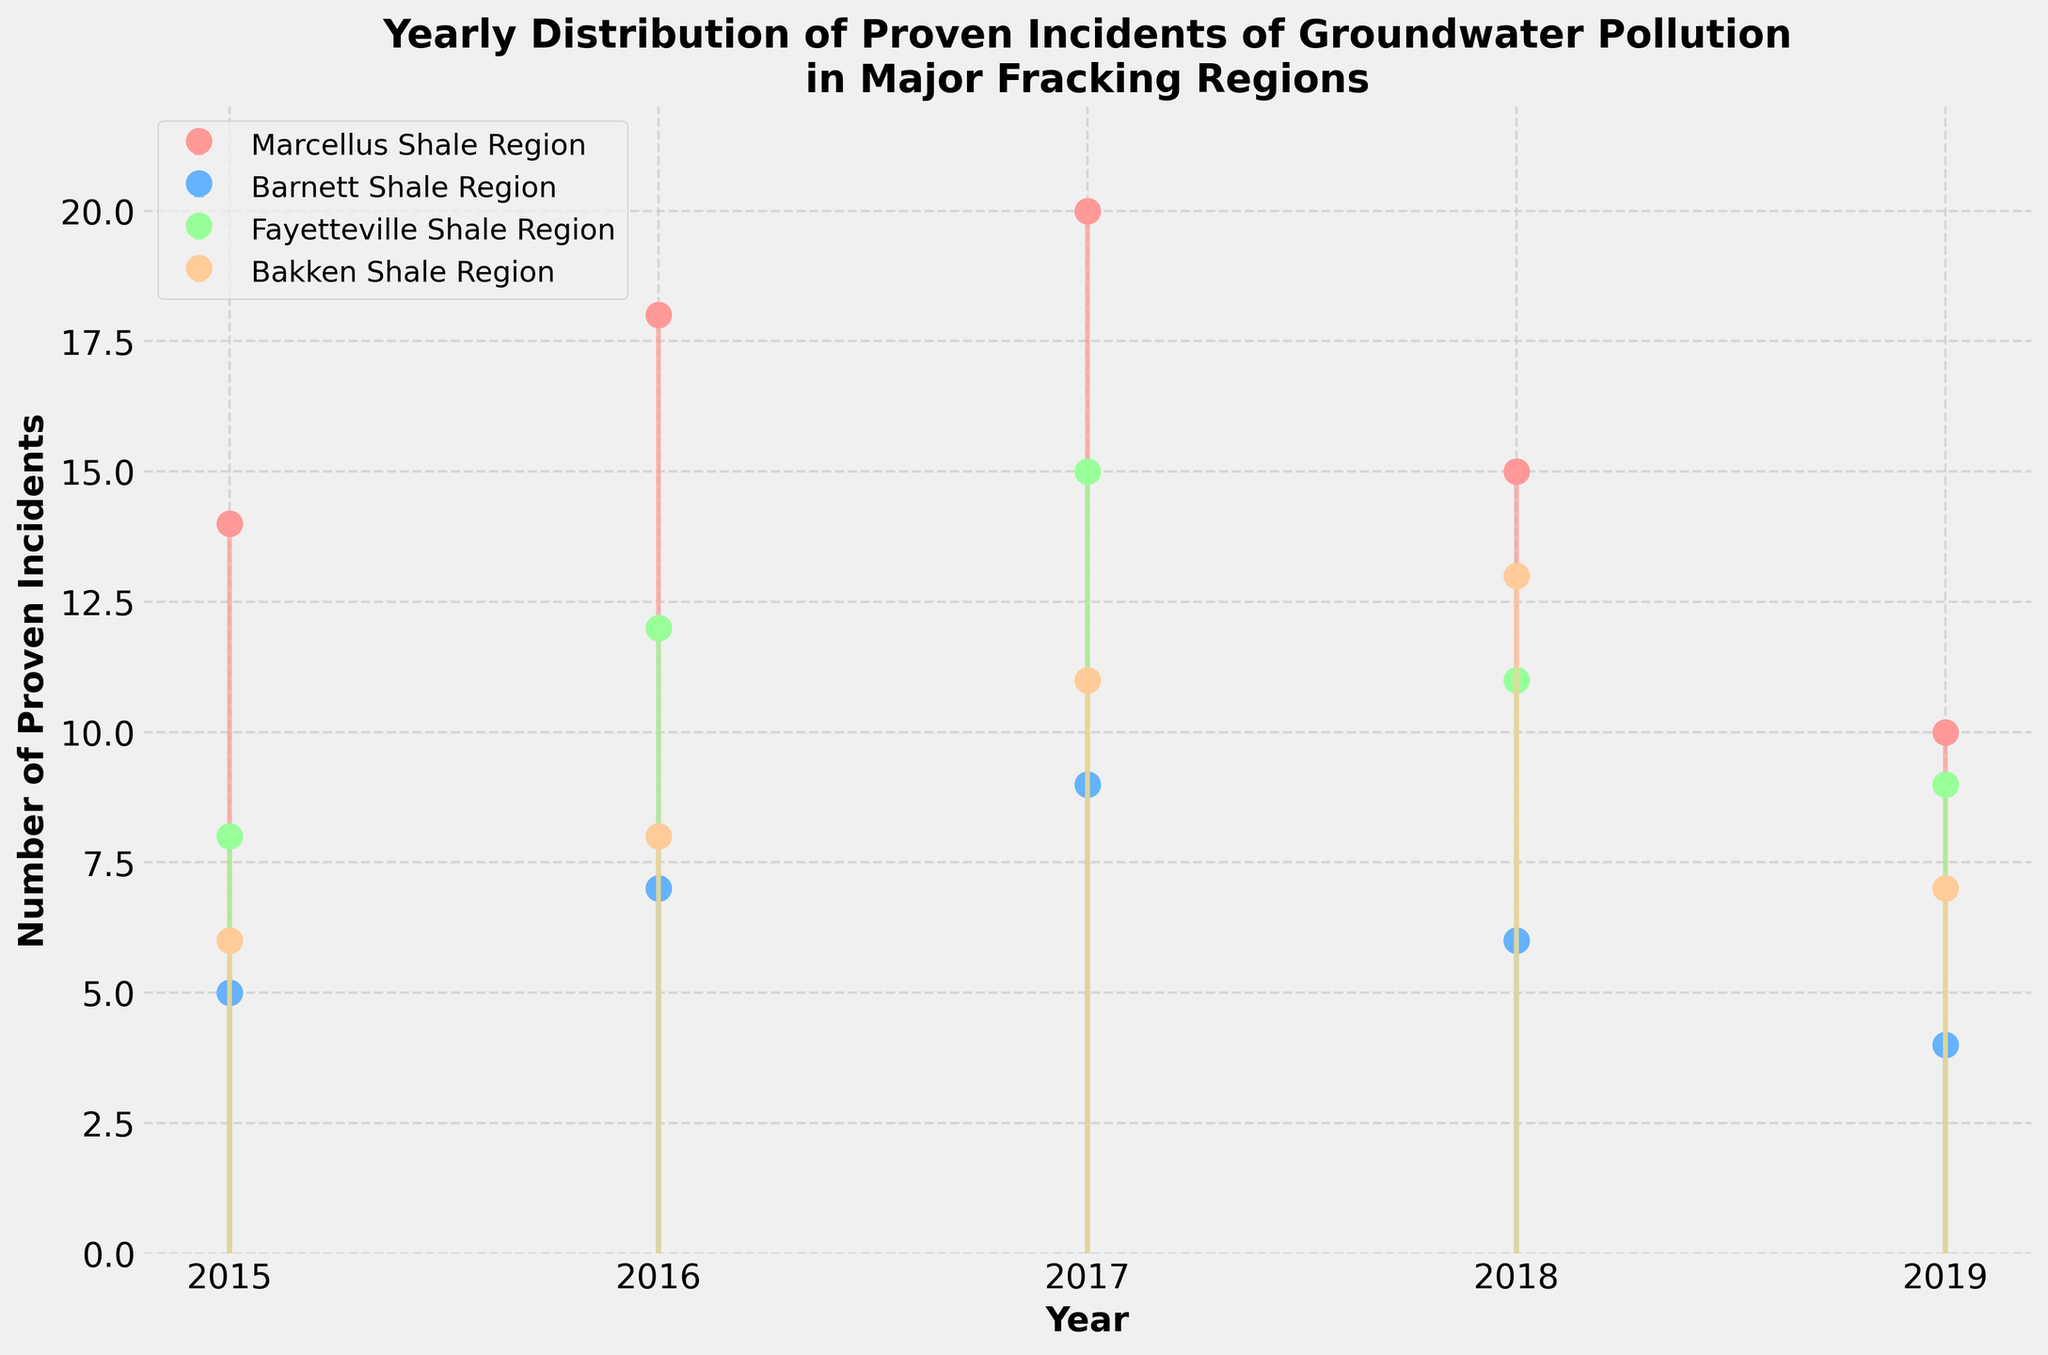What is the title of the figure? The title is usually displayed at the top of the figure. It helps in understanding what the graph is representing.
Answer: Yearly Distribution of Proven Incidents of Groundwater Pollution in Major Fracking Regions What is the range of years shown on the x-axis? The x-axis typically displays the range of time over which the data has been collected. Looking at the start and end years on the axis provides this range.
Answer: 2015 to 2019 Which region had the highest number of proven incidents in 2017? To identify this, look at the data points for the year 2017 across all regions and find the highest one.
Answer: Marcellus Shale Region How many proven incidents of groundwater pollution were there in the Fayetteville Shale Region in 2019? Navigate to the data points for the Fayetteville Shale Region and locate the value for 2019.
Answer: 9 Between which years did the Marcellus Shale Region see a decrease in proven incidents? Track the data points for the Marcellus Shale Region from 2015 to 2019 and identify where the number decreases.
Answer: 2017 to 2018, 2018 to 2019 What is the overall trend in the number of proven incidents in the Barnett Shale Region from 2015 to 2019? Examine the data points for the Barnett Shale Region across all years and identify the general pattern or direction.
Answer: Decreasing Which year had the highest number of proven incidents in both the Marcellus and Bakken Shale Regions combined? Add the number of incidents in each region for each year and compare the combined totals.
Answer: 2017 What is the average number of proven incidents in the Bakken Shale Region over the 5 years? Calculate the sum of proven incidents in the Bakken Shale Region from 2015 to 2019 and divide by 5.
Answer: 9 How does the trend in the number of proven incidents in the Marcellus Shale Region compare to the Barnett Shale Region over the years? Identify the directions (increasing or decreasing) for both regions and compare them year by year.
Answer: Marcellus generally increases and then decreases; Barnett steadily decreases 